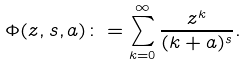Convert formula to latex. <formula><loc_0><loc_0><loc_500><loc_500>\Phi ( z , s , a ) \colon = \sum _ { k = 0 } ^ { \infty } \frac { z ^ { k } } { ( k + a ) ^ { s } } .</formula> 